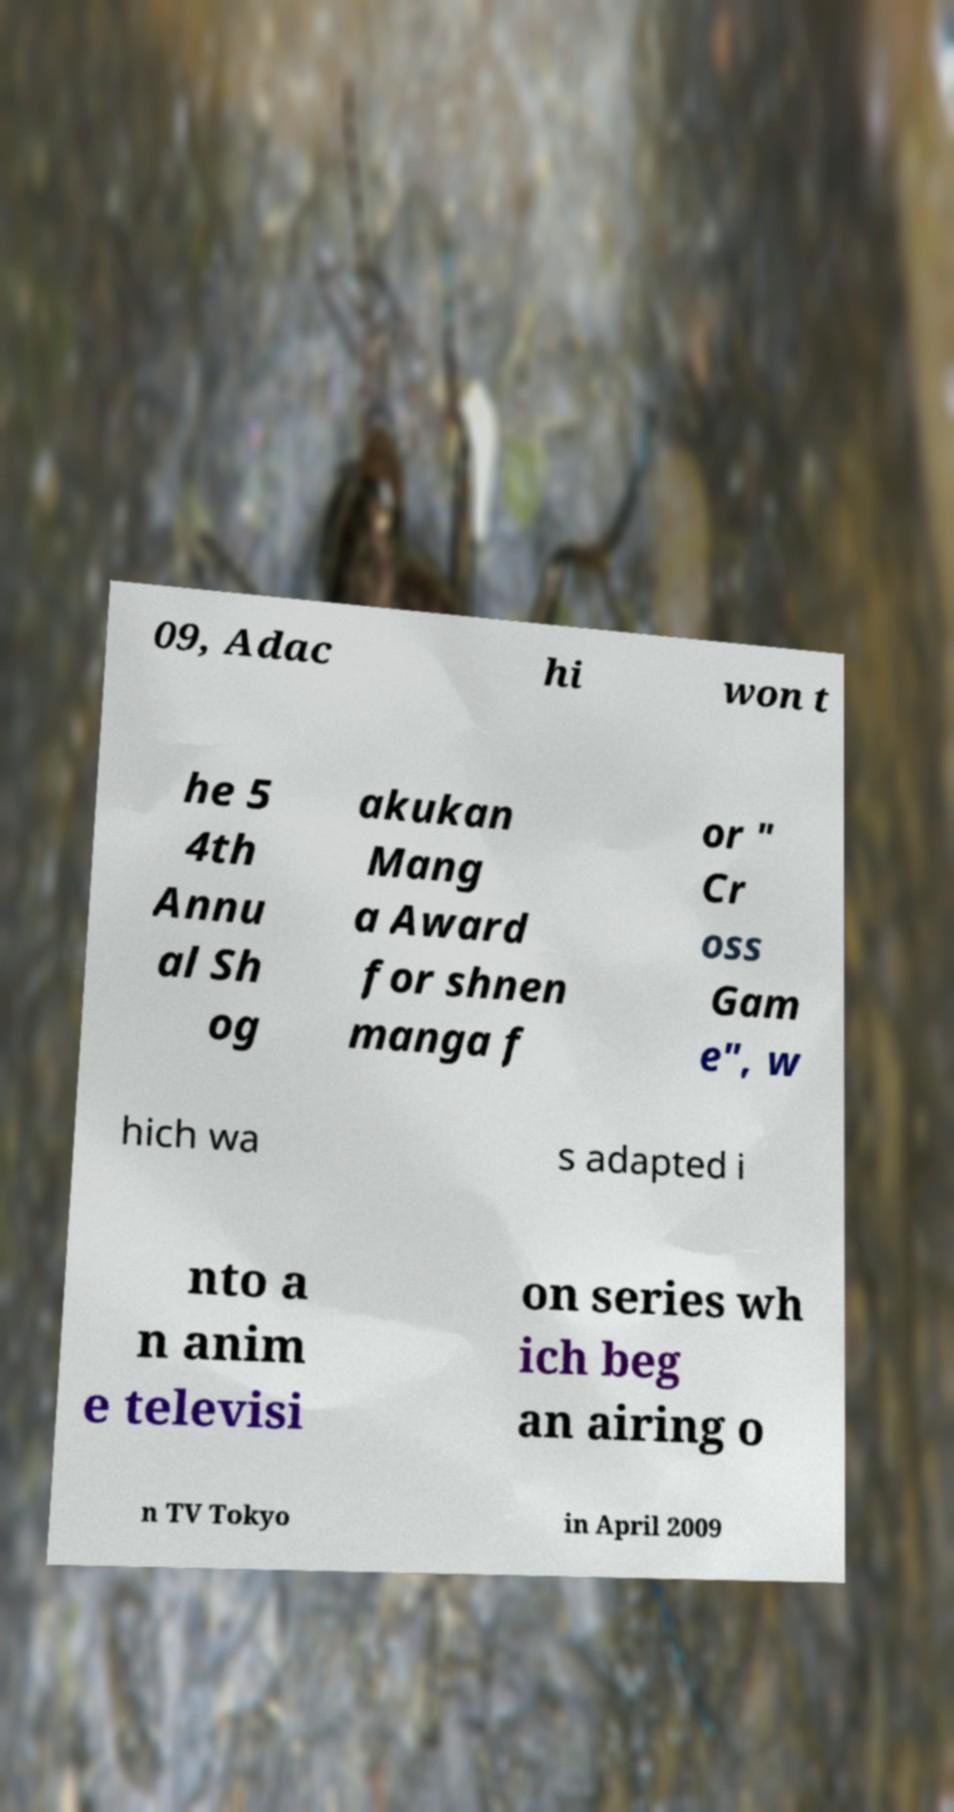Could you extract and type out the text from this image? 09, Adac hi won t he 5 4th Annu al Sh og akukan Mang a Award for shnen manga f or " Cr oss Gam e", w hich wa s adapted i nto a n anim e televisi on series wh ich beg an airing o n TV Tokyo in April 2009 